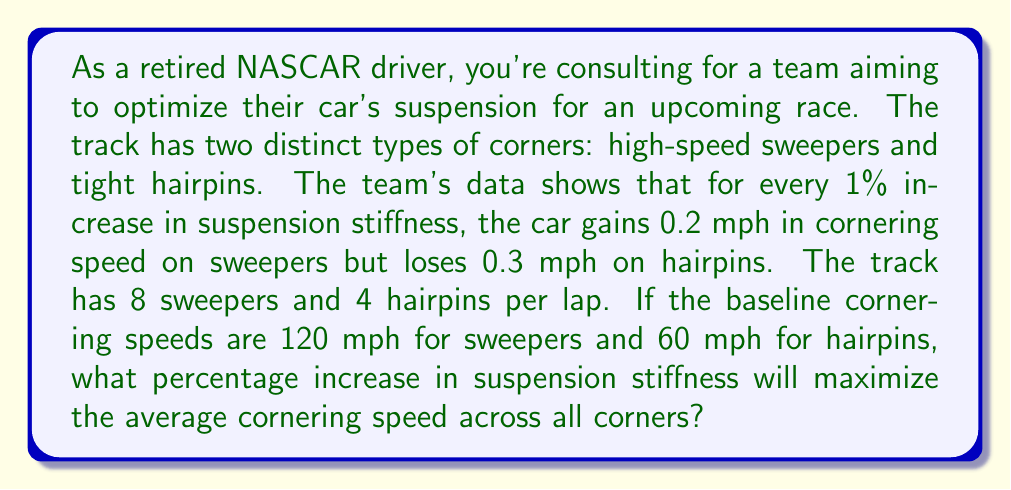Help me with this question. Let's approach this step-by-step:

1) Let $x$ be the percentage increase in suspension stiffness.

2) For sweepers:
   - Speed increase = $0.2x$ mph
   - New speed = $120 + 0.2x$ mph

3) For hairpins:
   - Speed decrease = $0.3x$ mph
   - New speed = $60 - 0.3x$ mph

4) To find the average cornering speed, we need to consider the number of each type of corner:
   $$\text{Average Speed} = \frac{8(120 + 0.2x) + 4(60 - 0.3x)}{12}$$

5) Simplify:
   $$\text{Average Speed} = \frac{960 + 1.6x + 240 - 1.2x}{12} = \frac{1200 + 0.4x}{12} = 100 + \frac{x}{30}$$

6) To maximize this, we need to find where its derivative equals zero:
   $$\frac{d}{dx}(100 + \frac{x}{30}) = \frac{1}{30}$$

7) The derivative is constant and positive, meaning the function always increases as $x$ increases.

8) However, we can't increase stiffness indefinitely. We need to consider the practical limits:
   - For sweepers: $120 + 0.2x > 0$
   - For hairpins: $60 - 0.3x > 0$

9) The hairpin condition is more restrictive:
   $$60 - 0.3x > 0$$
   $$-0.3x > -60$$
   $$x < 200$$

10) Therefore, the maximum average speed is achieved at the highest practical stiffness increase, which is just under 200%.
Answer: The optimal suspension stiffness increase is 199.99%, or practically 200%. 